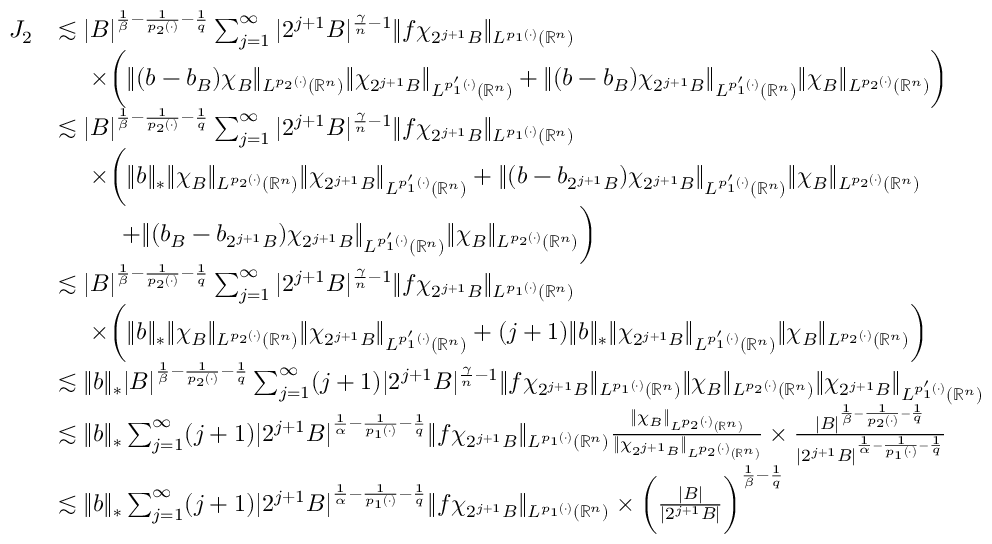Convert formula to latex. <formula><loc_0><loc_0><loc_500><loc_500>\begin{array} { r l } { J _ { 2 } } & { \lesssim | B | ^ { \frac { 1 } { \beta } - \frac { 1 } { p _ { 2 } ( \cdot ) } - \frac { 1 } { q } } \sum _ { j = 1 } ^ { \infty } | 2 ^ { j + 1 } B | ^ { \frac { \gamma } { n } - 1 } \| f \chi _ { 2 ^ { j + 1 } B } \| _ { L ^ { p _ { 1 } ( \cdot ) } ( \mathbb { R } ^ { n } ) } } \\ & { \times \left ( \| ( b - b _ { B } ) \chi _ { B } \| _ { L ^ { p _ { 2 } ( \cdot ) } ( \mathbb { R } ^ { n } ) } \| \chi _ { 2 ^ { j + 1 } B } \| _ { L ^ { p _ { 1 } ^ { \prime } ( \cdot ) } ( \mathbb { R } ^ { n } ) } + \| ( b - b _ { B } ) \chi _ { 2 ^ { j + 1 } B } \| _ { L ^ { p _ { 1 } ^ { \prime } ( \cdot ) } ( \mathbb { R } ^ { n } ) } \| \chi _ { B } \| _ { L ^ { p _ { 2 } ( \cdot ) } ( \mathbb { R } ^ { n } ) } \right ) } \\ & { \lesssim | B | ^ { \frac { 1 } { \beta } - \frac { 1 } { p _ { 2 } ( \cdot ) } - \frac { 1 } { q } } \sum _ { j = 1 } ^ { \infty } | 2 ^ { j + 1 } B | ^ { \frac { \gamma } { n } - 1 } \| f \chi _ { 2 ^ { j + 1 } B } \| _ { L ^ { p _ { 1 } ( \cdot ) } ( \mathbb { R } ^ { n } ) } } \\ & { \times \left ( \| b \| _ { * } \| \chi _ { B } \| _ { L ^ { p _ { 2 } ( \cdot ) } ( \mathbb { R } ^ { n } ) } \| \chi _ { 2 ^ { j + 1 } B } \| _ { L ^ { p _ { 1 } ^ { \prime } ( \cdot ) } ( \mathbb { R } ^ { n } ) } + \| ( b - b _ { 2 ^ { j + 1 } B } ) \chi _ { 2 ^ { j + 1 } B } \| _ { L ^ { p _ { 1 } ^ { \prime } ( \cdot ) } ( \mathbb { R } ^ { n } ) } \| \chi _ { B } \| _ { L ^ { p _ { 2 } ( \cdot ) } ( \mathbb { R } ^ { n } ) } } \\ & { + \| ( b _ { B } - b _ { 2 ^ { j + 1 } B } ) \chi _ { 2 ^ { j + 1 } B } \| _ { L ^ { p _ { 1 } ^ { \prime } ( \cdot ) } ( \mathbb { R } ^ { n } ) } \| \chi _ { B } \| _ { L ^ { p _ { 2 } ( \cdot ) } ( \mathbb { R } ^ { n } ) } \right ) } \\ & { \lesssim | B | ^ { \frac { 1 } { \beta } - \frac { 1 } { p _ { 2 } ( \cdot ) } - \frac { 1 } { q } } \sum _ { j = 1 } ^ { \infty } | 2 ^ { j + 1 } B | ^ { \frac { \gamma } { n } - 1 } \| f \chi _ { 2 ^ { j + 1 } B } \| _ { L ^ { p _ { 1 } ( \cdot ) } ( \mathbb { R } ^ { n } ) } } \\ & { \times \left ( \| b \| _ { * } \| \chi _ { B } \| _ { L ^ { p _ { 2 } ( \cdot ) } ( \mathbb { R } ^ { n } ) } \| \chi _ { 2 ^ { j + 1 } B } \| _ { L ^ { p _ { 1 } ^ { \prime } ( \cdot ) } ( \mathbb { R } ^ { n } ) } + ( j + 1 ) \| b \| _ { * } \| \chi _ { 2 ^ { j + 1 } B } \| _ { L ^ { p _ { 1 } ^ { \prime } ( \cdot ) } ( \mathbb { R } ^ { n } ) } \| \chi _ { B } \| _ { L ^ { p _ { 2 } ( \cdot ) } ( \mathbb { R } ^ { n } ) } \right ) } \\ & { \lesssim \| b \| _ { * } | B | ^ { \frac { 1 } { \beta } - \frac { 1 } { p _ { 2 } ( \cdot ) } - \frac { 1 } { q } } \sum _ { j = 1 } ^ { \infty } ( j + 1 ) | 2 ^ { j + 1 } B | ^ { \frac { \gamma } { n } - 1 } \| f \chi _ { 2 ^ { j + 1 } B } \| _ { L ^ { p _ { 1 } ( \cdot ) } ( \mathbb { R } ^ { n } ) } \| \chi _ { B } \| _ { L ^ { p _ { 2 } ( \cdot ) } ( \mathbb { R } ^ { n } ) } \| \chi _ { 2 ^ { j + 1 } B } \| _ { L ^ { p _ { 1 } ^ { \prime } ( \cdot ) } ( \mathbb { R } ^ { n } ) } } \\ & { \lesssim \| b \| _ { * } \sum _ { j = 1 } ^ { \infty } ( j + 1 ) | 2 ^ { j + 1 } B | ^ { \frac { 1 } { \alpha } - \frac { 1 } { p _ { 1 } ( \cdot ) } - \frac { 1 } { q } } \| f \chi _ { 2 ^ { j + 1 } B } \| _ { L ^ { p _ { 1 } ( \cdot ) } ( \mathbb { R } ^ { n } ) } \frac { \| \chi _ { B } \| _ { L ^ { p _ { 2 } ( \cdot ) } ( \mathbb { R } ^ { n } ) } } { \| \chi _ { 2 ^ { j + 1 } B } \| _ { L ^ { p _ { 2 } ( \cdot ) } ( \mathbb { R } ^ { n } ) } } \times \frac { | B | ^ { \frac { 1 } { \beta } - \frac { 1 } { p _ { 2 } ( \cdot ) } - \frac { 1 } { q } } } { | 2 ^ { j + 1 } B | ^ { \frac { 1 } { \alpha } - \frac { 1 } { p _ { 1 } ( \cdot ) } - \frac { 1 } { q } } } } \\ & { \lesssim \| b \| _ { * } \sum _ { j = 1 } ^ { \infty } ( j + 1 ) | 2 ^ { j + 1 } B | ^ { \frac { 1 } { \alpha } - \frac { 1 } { p _ { 1 } ( \cdot ) } - \frac { 1 } { q } } \| f \chi _ { 2 ^ { j + 1 } B } \| _ { L ^ { p _ { 1 } ( \cdot ) } ( \mathbb { R } ^ { n } ) } \times \left ( \frac { | B | } { | 2 ^ { j + 1 } B | } \right ) ^ { \frac { 1 } { \beta } - \frac { 1 } { q } } } \end{array}</formula> 